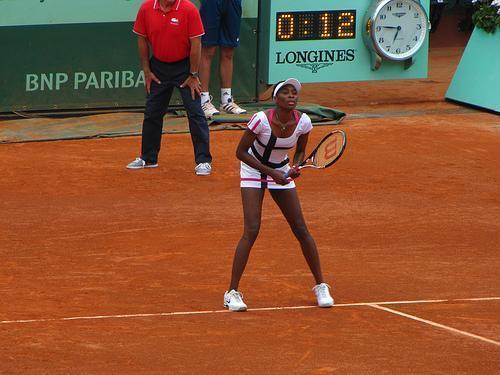How many players are there?
Give a very brief answer. 1. 